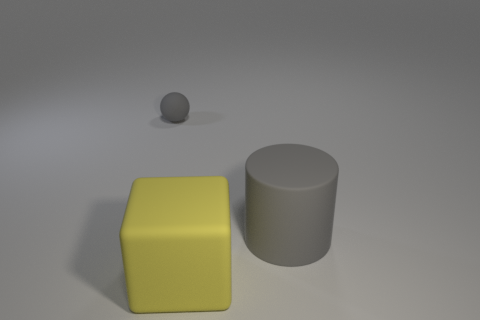Are there the same number of things behind the large yellow thing and gray cylinders? No, there are not an equal number of items behind the large yellow cube and the gray cylinder. Behind the yellow cube, there appears to be one smaller gray sphere, while there's nothing visible behind the gray cylinder. 